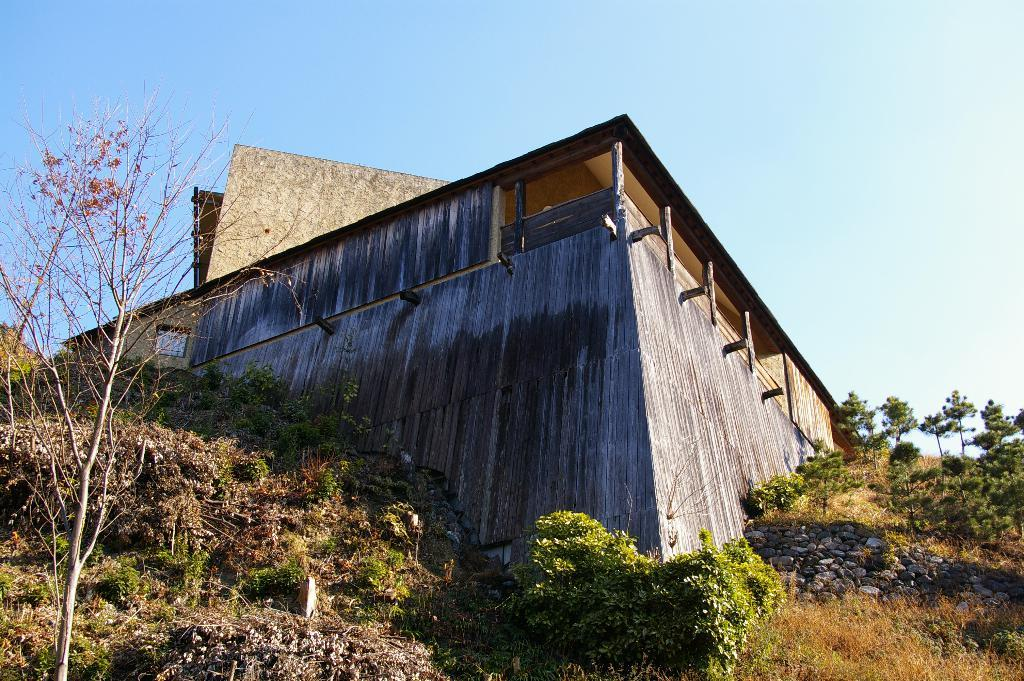What type of structure is present in the image? There is a building in the image. What can be seen near the building? There are trees, plants, and stones near the building. What is visible in the background of the image? The sky is visible in the background of the image. Can you see a girl walking in the image? There is no girl present in the image. What type of land is visible in the image? The image does not show any specific type of land; it only features a building, trees, plants, stones, and the sky. 